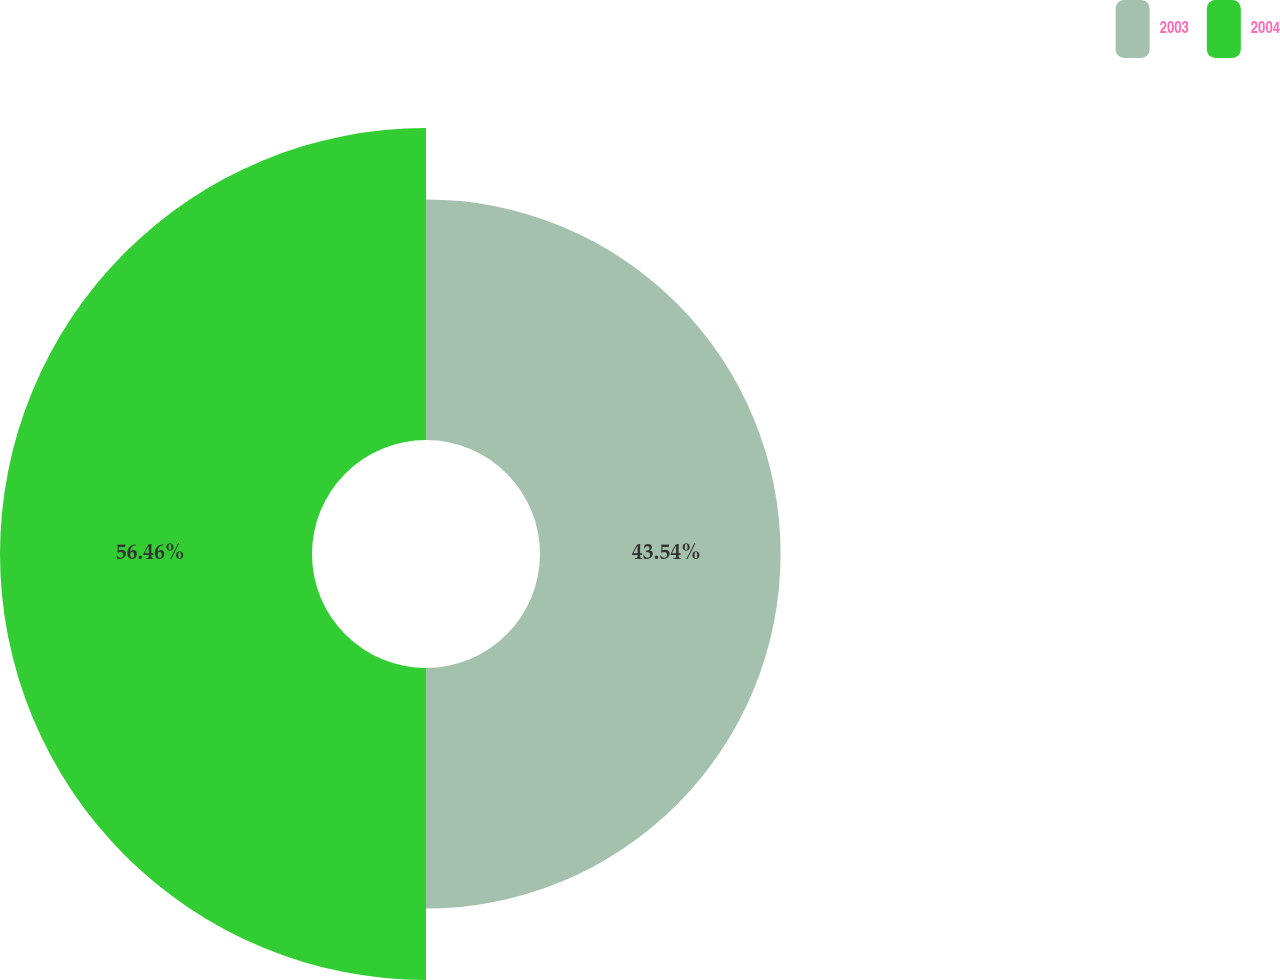Convert chart. <chart><loc_0><loc_0><loc_500><loc_500><pie_chart><fcel>2003<fcel>2004<nl><fcel>43.54%<fcel>56.46%<nl></chart> 